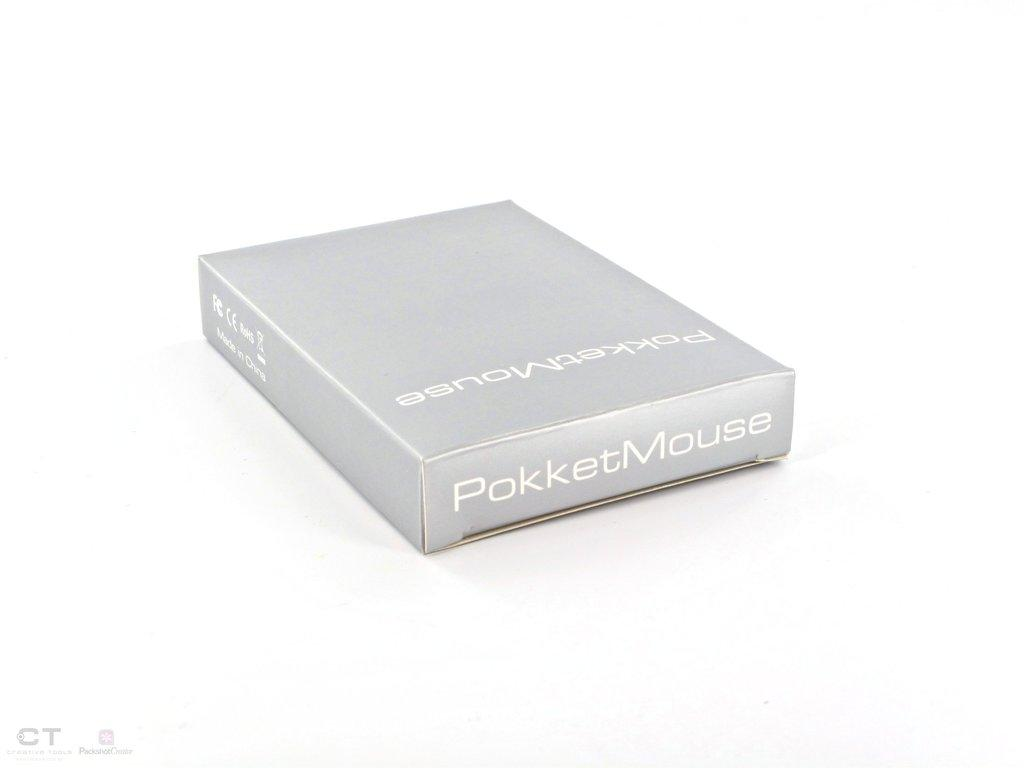<image>
Render a clear and concise summary of the photo. A silver closed box with the label PokketMouse on the side. 